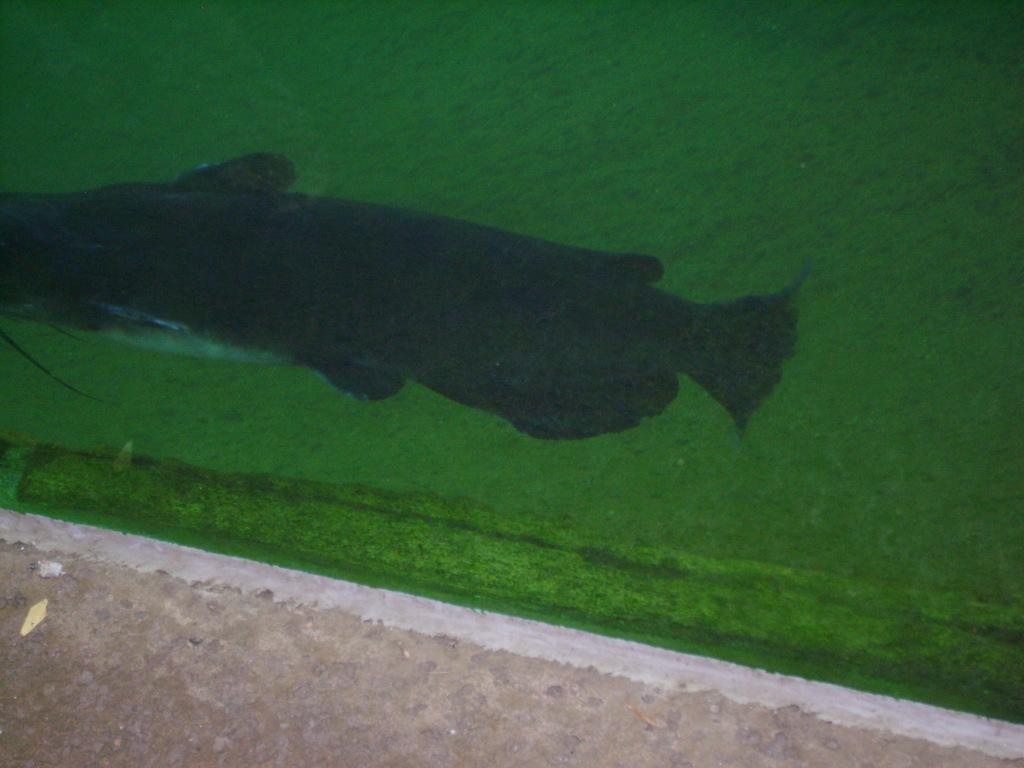What is in the water in the image? There is a fish in the water in the image. What can be seen in the background of the image? The background of the image is green. Where is the grandfather sitting on his throne in the image? There is no grandfather or throne present in the image; it only features a fish in the water and a green background. 